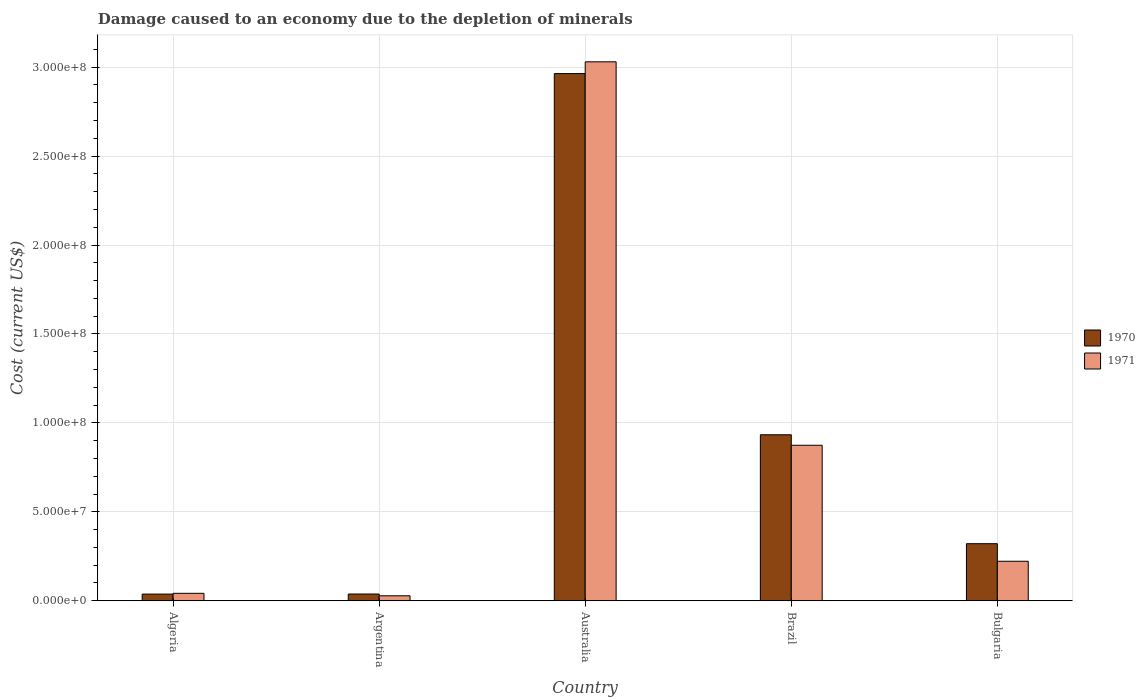How many different coloured bars are there?
Provide a short and direct response. 2. How many groups of bars are there?
Give a very brief answer. 5. Are the number of bars per tick equal to the number of legend labels?
Ensure brevity in your answer.  Yes. Are the number of bars on each tick of the X-axis equal?
Provide a short and direct response. Yes. How many bars are there on the 5th tick from the left?
Make the answer very short. 2. How many bars are there on the 3rd tick from the right?
Your response must be concise. 2. What is the label of the 5th group of bars from the left?
Ensure brevity in your answer.  Bulgaria. In how many cases, is the number of bars for a given country not equal to the number of legend labels?
Your response must be concise. 0. What is the cost of damage caused due to the depletion of minerals in 1971 in Australia?
Provide a short and direct response. 3.03e+08. Across all countries, what is the maximum cost of damage caused due to the depletion of minerals in 1970?
Your answer should be compact. 2.96e+08. Across all countries, what is the minimum cost of damage caused due to the depletion of minerals in 1971?
Keep it short and to the point. 2.80e+06. In which country was the cost of damage caused due to the depletion of minerals in 1970 maximum?
Provide a short and direct response. Australia. What is the total cost of damage caused due to the depletion of minerals in 1970 in the graph?
Provide a short and direct response. 4.29e+08. What is the difference between the cost of damage caused due to the depletion of minerals in 1971 in Brazil and that in Bulgaria?
Your answer should be compact. 6.52e+07. What is the difference between the cost of damage caused due to the depletion of minerals in 1971 in Algeria and the cost of damage caused due to the depletion of minerals in 1970 in Argentina?
Provide a short and direct response. 3.93e+05. What is the average cost of damage caused due to the depletion of minerals in 1970 per country?
Keep it short and to the point. 8.59e+07. What is the difference between the cost of damage caused due to the depletion of minerals of/in 1971 and cost of damage caused due to the depletion of minerals of/in 1970 in Brazil?
Keep it short and to the point. -5.90e+06. What is the ratio of the cost of damage caused due to the depletion of minerals in 1971 in Argentina to that in Bulgaria?
Give a very brief answer. 0.13. Is the cost of damage caused due to the depletion of minerals in 1970 in Australia less than that in Bulgaria?
Provide a succinct answer. No. What is the difference between the highest and the second highest cost of damage caused due to the depletion of minerals in 1970?
Offer a very short reply. -6.12e+07. What is the difference between the highest and the lowest cost of damage caused due to the depletion of minerals in 1970?
Offer a very short reply. 2.93e+08. Is the sum of the cost of damage caused due to the depletion of minerals in 1971 in Algeria and Bulgaria greater than the maximum cost of damage caused due to the depletion of minerals in 1970 across all countries?
Make the answer very short. No. Are all the bars in the graph horizontal?
Offer a very short reply. No. What is the difference between two consecutive major ticks on the Y-axis?
Provide a short and direct response. 5.00e+07. How many legend labels are there?
Ensure brevity in your answer.  2. What is the title of the graph?
Offer a terse response. Damage caused to an economy due to the depletion of minerals. Does "1973" appear as one of the legend labels in the graph?
Offer a terse response. No. What is the label or title of the X-axis?
Offer a very short reply. Country. What is the label or title of the Y-axis?
Give a very brief answer. Cost (current US$). What is the Cost (current US$) of 1970 in Algeria?
Your answer should be very brief. 3.76e+06. What is the Cost (current US$) in 1971 in Algeria?
Ensure brevity in your answer.  4.19e+06. What is the Cost (current US$) of 1970 in Argentina?
Your answer should be compact. 3.80e+06. What is the Cost (current US$) in 1971 in Argentina?
Offer a terse response. 2.80e+06. What is the Cost (current US$) of 1970 in Australia?
Ensure brevity in your answer.  2.96e+08. What is the Cost (current US$) of 1971 in Australia?
Offer a terse response. 3.03e+08. What is the Cost (current US$) of 1970 in Brazil?
Provide a succinct answer. 9.33e+07. What is the Cost (current US$) in 1971 in Brazil?
Offer a terse response. 8.74e+07. What is the Cost (current US$) of 1970 in Bulgaria?
Offer a terse response. 3.21e+07. What is the Cost (current US$) of 1971 in Bulgaria?
Your response must be concise. 2.22e+07. Across all countries, what is the maximum Cost (current US$) in 1970?
Ensure brevity in your answer.  2.96e+08. Across all countries, what is the maximum Cost (current US$) in 1971?
Provide a succinct answer. 3.03e+08. Across all countries, what is the minimum Cost (current US$) in 1970?
Your response must be concise. 3.76e+06. Across all countries, what is the minimum Cost (current US$) in 1971?
Provide a succinct answer. 2.80e+06. What is the total Cost (current US$) of 1970 in the graph?
Keep it short and to the point. 4.29e+08. What is the total Cost (current US$) of 1971 in the graph?
Give a very brief answer. 4.20e+08. What is the difference between the Cost (current US$) in 1970 in Algeria and that in Argentina?
Give a very brief answer. -3.55e+04. What is the difference between the Cost (current US$) of 1971 in Algeria and that in Argentina?
Offer a very short reply. 1.39e+06. What is the difference between the Cost (current US$) of 1970 in Algeria and that in Australia?
Offer a very short reply. -2.93e+08. What is the difference between the Cost (current US$) in 1971 in Algeria and that in Australia?
Offer a very short reply. -2.99e+08. What is the difference between the Cost (current US$) of 1970 in Algeria and that in Brazil?
Provide a succinct answer. -8.96e+07. What is the difference between the Cost (current US$) of 1971 in Algeria and that in Brazil?
Provide a succinct answer. -8.32e+07. What is the difference between the Cost (current US$) in 1970 in Algeria and that in Bulgaria?
Offer a very short reply. -2.83e+07. What is the difference between the Cost (current US$) of 1971 in Algeria and that in Bulgaria?
Your answer should be compact. -1.80e+07. What is the difference between the Cost (current US$) of 1970 in Argentina and that in Australia?
Your answer should be compact. -2.93e+08. What is the difference between the Cost (current US$) in 1971 in Argentina and that in Australia?
Your answer should be very brief. -3.00e+08. What is the difference between the Cost (current US$) in 1970 in Argentina and that in Brazil?
Give a very brief answer. -8.95e+07. What is the difference between the Cost (current US$) in 1971 in Argentina and that in Brazil?
Your answer should be compact. -8.46e+07. What is the difference between the Cost (current US$) of 1970 in Argentina and that in Bulgaria?
Provide a succinct answer. -2.83e+07. What is the difference between the Cost (current US$) in 1971 in Argentina and that in Bulgaria?
Make the answer very short. -1.94e+07. What is the difference between the Cost (current US$) of 1970 in Australia and that in Brazil?
Your answer should be very brief. 2.03e+08. What is the difference between the Cost (current US$) in 1971 in Australia and that in Brazil?
Ensure brevity in your answer.  2.16e+08. What is the difference between the Cost (current US$) in 1970 in Australia and that in Bulgaria?
Keep it short and to the point. 2.64e+08. What is the difference between the Cost (current US$) in 1971 in Australia and that in Bulgaria?
Keep it short and to the point. 2.81e+08. What is the difference between the Cost (current US$) in 1970 in Brazil and that in Bulgaria?
Offer a terse response. 6.12e+07. What is the difference between the Cost (current US$) in 1971 in Brazil and that in Bulgaria?
Make the answer very short. 6.52e+07. What is the difference between the Cost (current US$) in 1970 in Algeria and the Cost (current US$) in 1971 in Argentina?
Offer a very short reply. 9.59e+05. What is the difference between the Cost (current US$) of 1970 in Algeria and the Cost (current US$) of 1971 in Australia?
Your answer should be compact. -2.99e+08. What is the difference between the Cost (current US$) in 1970 in Algeria and the Cost (current US$) in 1971 in Brazil?
Make the answer very short. -8.37e+07. What is the difference between the Cost (current US$) in 1970 in Algeria and the Cost (current US$) in 1971 in Bulgaria?
Your answer should be very brief. -1.85e+07. What is the difference between the Cost (current US$) of 1970 in Argentina and the Cost (current US$) of 1971 in Australia?
Your response must be concise. -2.99e+08. What is the difference between the Cost (current US$) in 1970 in Argentina and the Cost (current US$) in 1971 in Brazil?
Keep it short and to the point. -8.36e+07. What is the difference between the Cost (current US$) of 1970 in Argentina and the Cost (current US$) of 1971 in Bulgaria?
Your response must be concise. -1.84e+07. What is the difference between the Cost (current US$) in 1970 in Australia and the Cost (current US$) in 1971 in Brazil?
Keep it short and to the point. 2.09e+08. What is the difference between the Cost (current US$) of 1970 in Australia and the Cost (current US$) of 1971 in Bulgaria?
Provide a succinct answer. 2.74e+08. What is the difference between the Cost (current US$) in 1970 in Brazil and the Cost (current US$) in 1971 in Bulgaria?
Offer a very short reply. 7.11e+07. What is the average Cost (current US$) of 1970 per country?
Offer a terse response. 8.59e+07. What is the average Cost (current US$) in 1971 per country?
Provide a short and direct response. 8.39e+07. What is the difference between the Cost (current US$) of 1970 and Cost (current US$) of 1971 in Algeria?
Provide a short and direct response. -4.28e+05. What is the difference between the Cost (current US$) of 1970 and Cost (current US$) of 1971 in Argentina?
Your answer should be very brief. 9.95e+05. What is the difference between the Cost (current US$) of 1970 and Cost (current US$) of 1971 in Australia?
Give a very brief answer. -6.62e+06. What is the difference between the Cost (current US$) of 1970 and Cost (current US$) of 1971 in Brazil?
Offer a very short reply. 5.90e+06. What is the difference between the Cost (current US$) of 1970 and Cost (current US$) of 1971 in Bulgaria?
Ensure brevity in your answer.  9.88e+06. What is the ratio of the Cost (current US$) in 1971 in Algeria to that in Argentina?
Provide a short and direct response. 1.5. What is the ratio of the Cost (current US$) of 1970 in Algeria to that in Australia?
Ensure brevity in your answer.  0.01. What is the ratio of the Cost (current US$) in 1971 in Algeria to that in Australia?
Ensure brevity in your answer.  0.01. What is the ratio of the Cost (current US$) in 1970 in Algeria to that in Brazil?
Ensure brevity in your answer.  0.04. What is the ratio of the Cost (current US$) of 1971 in Algeria to that in Brazil?
Give a very brief answer. 0.05. What is the ratio of the Cost (current US$) of 1970 in Algeria to that in Bulgaria?
Offer a very short reply. 0.12. What is the ratio of the Cost (current US$) in 1971 in Algeria to that in Bulgaria?
Give a very brief answer. 0.19. What is the ratio of the Cost (current US$) of 1970 in Argentina to that in Australia?
Your answer should be very brief. 0.01. What is the ratio of the Cost (current US$) of 1971 in Argentina to that in Australia?
Your response must be concise. 0.01. What is the ratio of the Cost (current US$) in 1970 in Argentina to that in Brazil?
Offer a very short reply. 0.04. What is the ratio of the Cost (current US$) in 1971 in Argentina to that in Brazil?
Your response must be concise. 0.03. What is the ratio of the Cost (current US$) in 1970 in Argentina to that in Bulgaria?
Provide a succinct answer. 0.12. What is the ratio of the Cost (current US$) of 1971 in Argentina to that in Bulgaria?
Offer a very short reply. 0.13. What is the ratio of the Cost (current US$) in 1970 in Australia to that in Brazil?
Keep it short and to the point. 3.18. What is the ratio of the Cost (current US$) of 1971 in Australia to that in Brazil?
Provide a succinct answer. 3.47. What is the ratio of the Cost (current US$) of 1970 in Australia to that in Bulgaria?
Make the answer very short. 9.24. What is the ratio of the Cost (current US$) in 1971 in Australia to that in Bulgaria?
Keep it short and to the point. 13.64. What is the ratio of the Cost (current US$) of 1970 in Brazil to that in Bulgaria?
Your answer should be very brief. 2.91. What is the ratio of the Cost (current US$) of 1971 in Brazil to that in Bulgaria?
Offer a terse response. 3.94. What is the difference between the highest and the second highest Cost (current US$) in 1970?
Your response must be concise. 2.03e+08. What is the difference between the highest and the second highest Cost (current US$) in 1971?
Make the answer very short. 2.16e+08. What is the difference between the highest and the lowest Cost (current US$) of 1970?
Provide a succinct answer. 2.93e+08. What is the difference between the highest and the lowest Cost (current US$) of 1971?
Offer a terse response. 3.00e+08. 